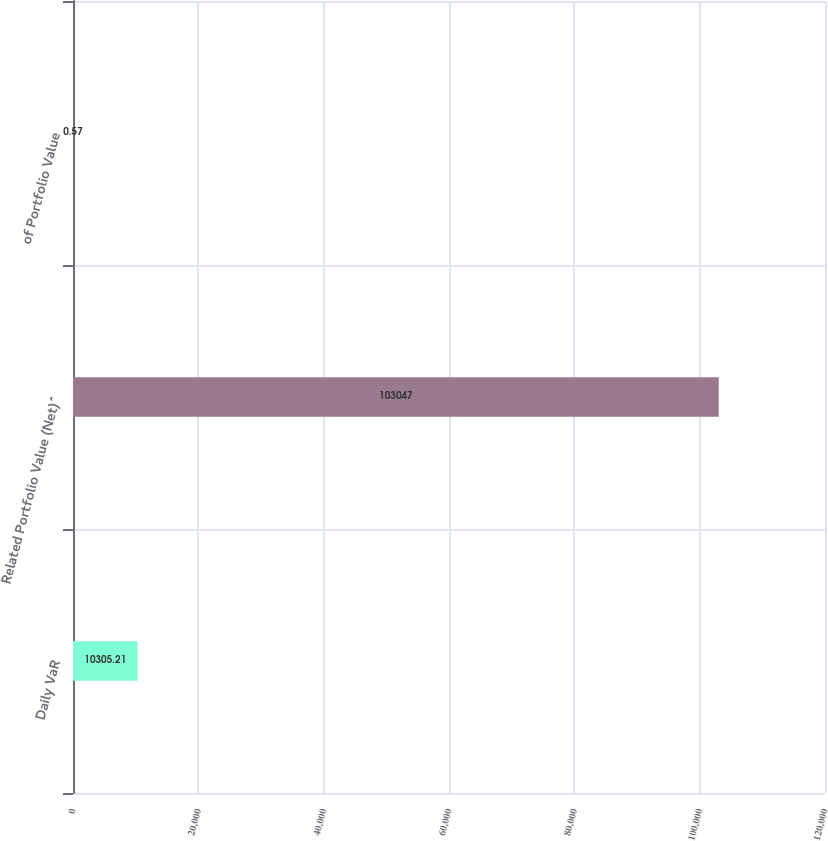<chart> <loc_0><loc_0><loc_500><loc_500><bar_chart><fcel>Daily VaR<fcel>Related Portfolio Value (Net)^<fcel>of Portfolio Value<nl><fcel>10305.2<fcel>103047<fcel>0.57<nl></chart> 